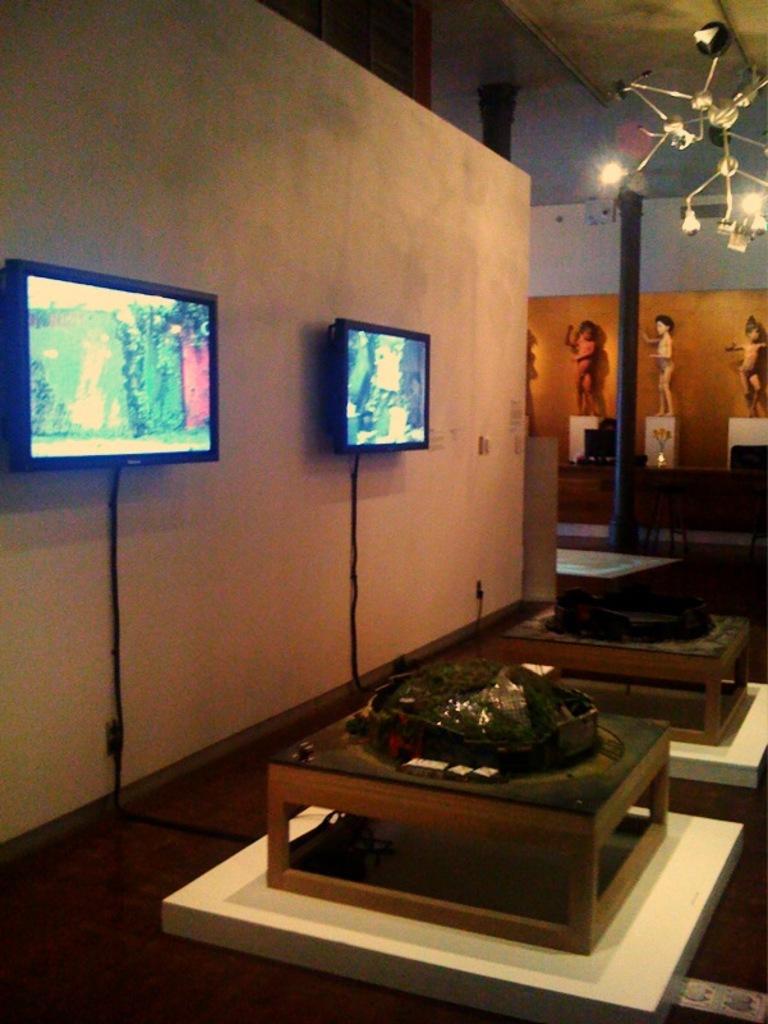Please provide a concise description of this image. In this image on the left side there is a wall , on the wall two systems attached , in front of wall there are small tables , on the table I can see some objects , in the middle there is a pole , there are some sculptures ,there is a chandelier attached to the roof. 